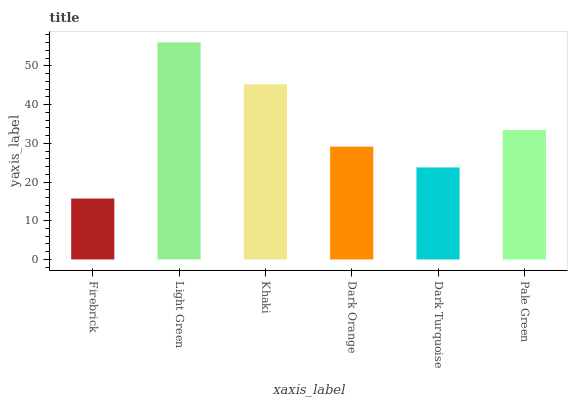Is Firebrick the minimum?
Answer yes or no. Yes. Is Light Green the maximum?
Answer yes or no. Yes. Is Khaki the minimum?
Answer yes or no. No. Is Khaki the maximum?
Answer yes or no. No. Is Light Green greater than Khaki?
Answer yes or no. Yes. Is Khaki less than Light Green?
Answer yes or no. Yes. Is Khaki greater than Light Green?
Answer yes or no. No. Is Light Green less than Khaki?
Answer yes or no. No. Is Pale Green the high median?
Answer yes or no. Yes. Is Dark Orange the low median?
Answer yes or no. Yes. Is Dark Turquoise the high median?
Answer yes or no. No. Is Firebrick the low median?
Answer yes or no. No. 